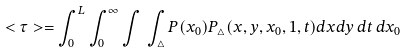<formula> <loc_0><loc_0><loc_500><loc_500>< \tau > = \int _ { 0 } ^ { L } \int _ { 0 } ^ { \infty } \int \, \int _ { \triangle } P ( x _ { 0 } ) P _ { \triangle } ( x , y , x _ { 0 } , 1 , t ) d x d y \, d t \, d x _ { 0 }</formula> 